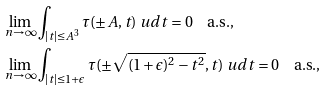<formula> <loc_0><loc_0><loc_500><loc_500>\lim _ { n \rightarrow \infty } & \int _ { | t | \leq A ^ { 3 } } \tau ( \pm A , t ) \ u d t = 0 \quad \text {a.s.,} \\ \lim _ { n \rightarrow \infty } & \int _ { | t | \leq 1 + \epsilon } \tau ( \pm \sqrt { ( 1 + \epsilon ) ^ { 2 } - t ^ { 2 } } , t ) \ u d t = 0 \quad \text {a.s.,}</formula> 